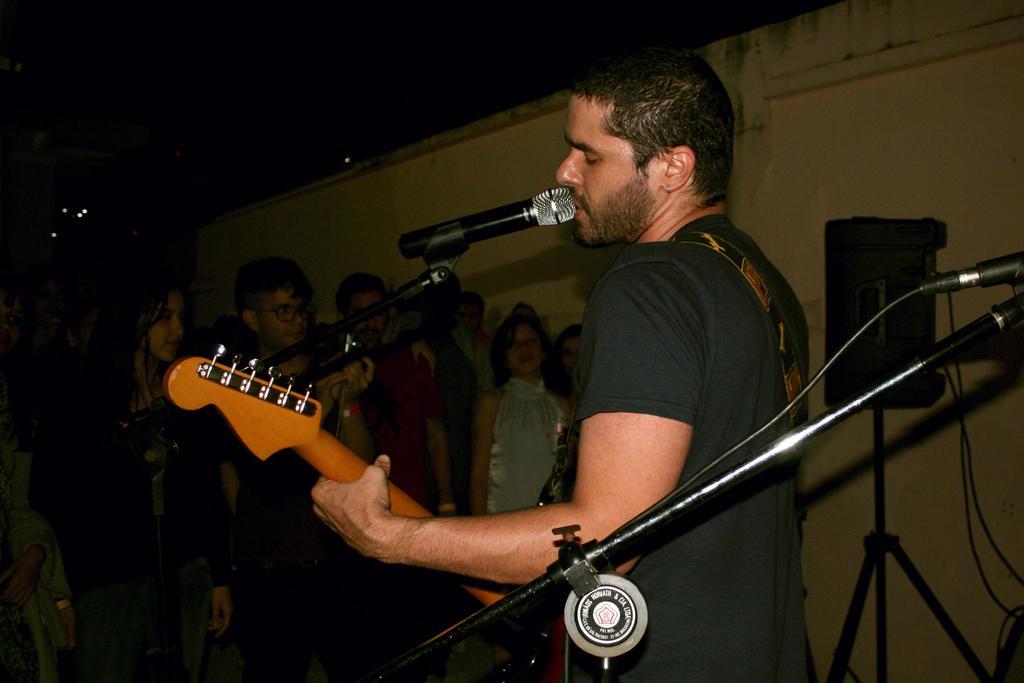How would you summarize this image in a sentence or two? In this image I can see a man wearing t-shirt, playing the guitar and it seems like he is also singing the song. In the background there are few people standing and looking at this person. On the right side there is a wall and also there is a speaker. 